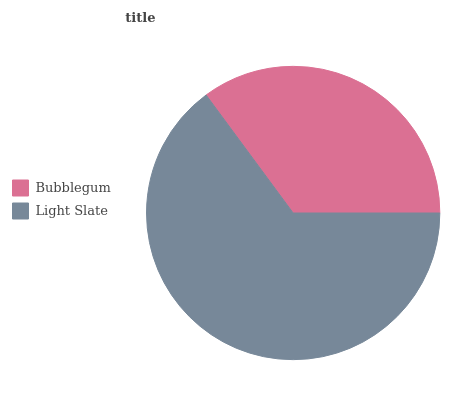Is Bubblegum the minimum?
Answer yes or no. Yes. Is Light Slate the maximum?
Answer yes or no. Yes. Is Light Slate the minimum?
Answer yes or no. No. Is Light Slate greater than Bubblegum?
Answer yes or no. Yes. Is Bubblegum less than Light Slate?
Answer yes or no. Yes. Is Bubblegum greater than Light Slate?
Answer yes or no. No. Is Light Slate less than Bubblegum?
Answer yes or no. No. Is Light Slate the high median?
Answer yes or no. Yes. Is Bubblegum the low median?
Answer yes or no. Yes. Is Bubblegum the high median?
Answer yes or no. No. Is Light Slate the low median?
Answer yes or no. No. 